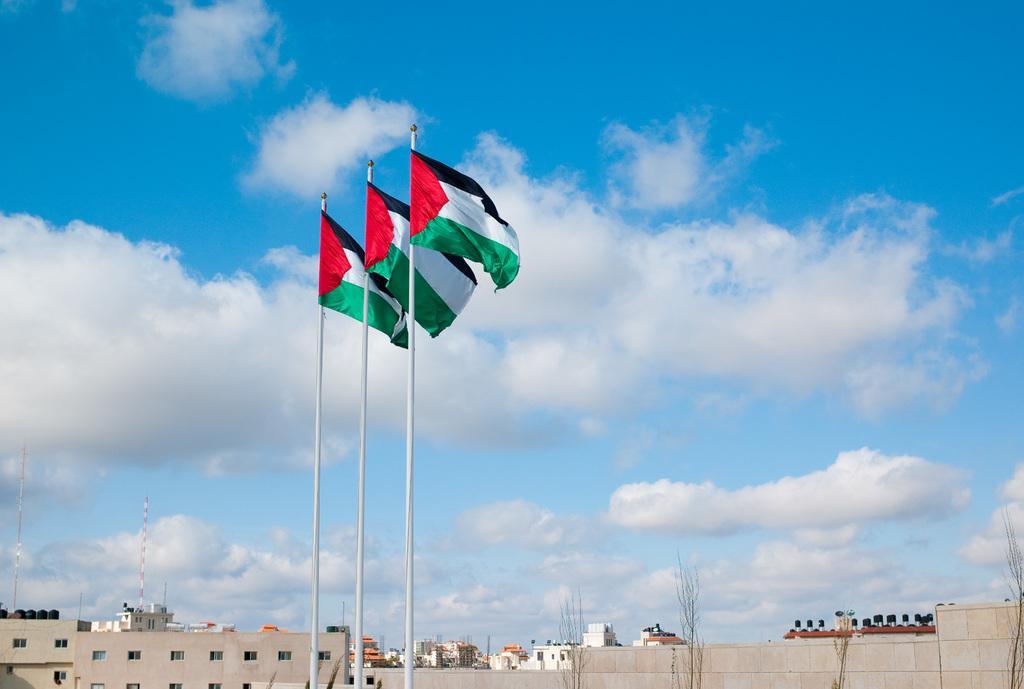In one or two sentences, can you explain what this image depicts? In this image, in the middle, we can see three flags. In the background, we can see some buildings, trees, houses, electric pole. At the top, we can see a sky. 